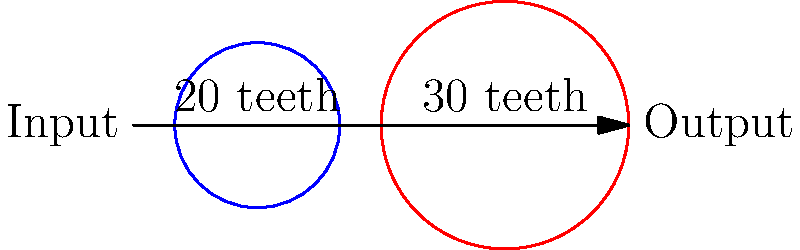In honor of Jamal Khashoggi's passion for precision and accuracy, let's analyze a gear system he might have discussed. A simple gear train consists of two gears: an input gear with 20 teeth and an output gear with 30 teeth. If the input gear rotates at 1200 rpm, what is the speed of the output gear in rpm? Let's approach this step-by-step, as Khashoggi would have encouraged:

1) First, recall the fundamental relationship for gear ratios:
   $$\frac{\text{Input Speed}}{\text{Output Speed}} = \frac{\text{Output Teeth}}{\text{Input Teeth}}$$

2) We know:
   - Input gear: 20 teeth, rotating at 1200 rpm
   - Output gear: 30 teeth, speed unknown

3) Let's substitute these values into our equation:
   $$\frac{1200 \text{ rpm}}{\text{Output Speed}} = \frac{30}{20}$$

4) Simplify the right side:
   $$\frac{1200 \text{ rpm}}{\text{Output Speed}} = 1.5$$

5) To solve for the output speed, multiply both sides by "Output Speed":
   $$1200 \text{ rpm} = 1.5 \times \text{Output Speed}$$

6) Divide both sides by 1.5:
   $$\text{Output Speed} = \frac{1200 \text{ rpm}}{1.5} = 800 \text{ rpm}$$

Thus, the output gear rotates at 800 rpm.
Answer: 800 rpm 